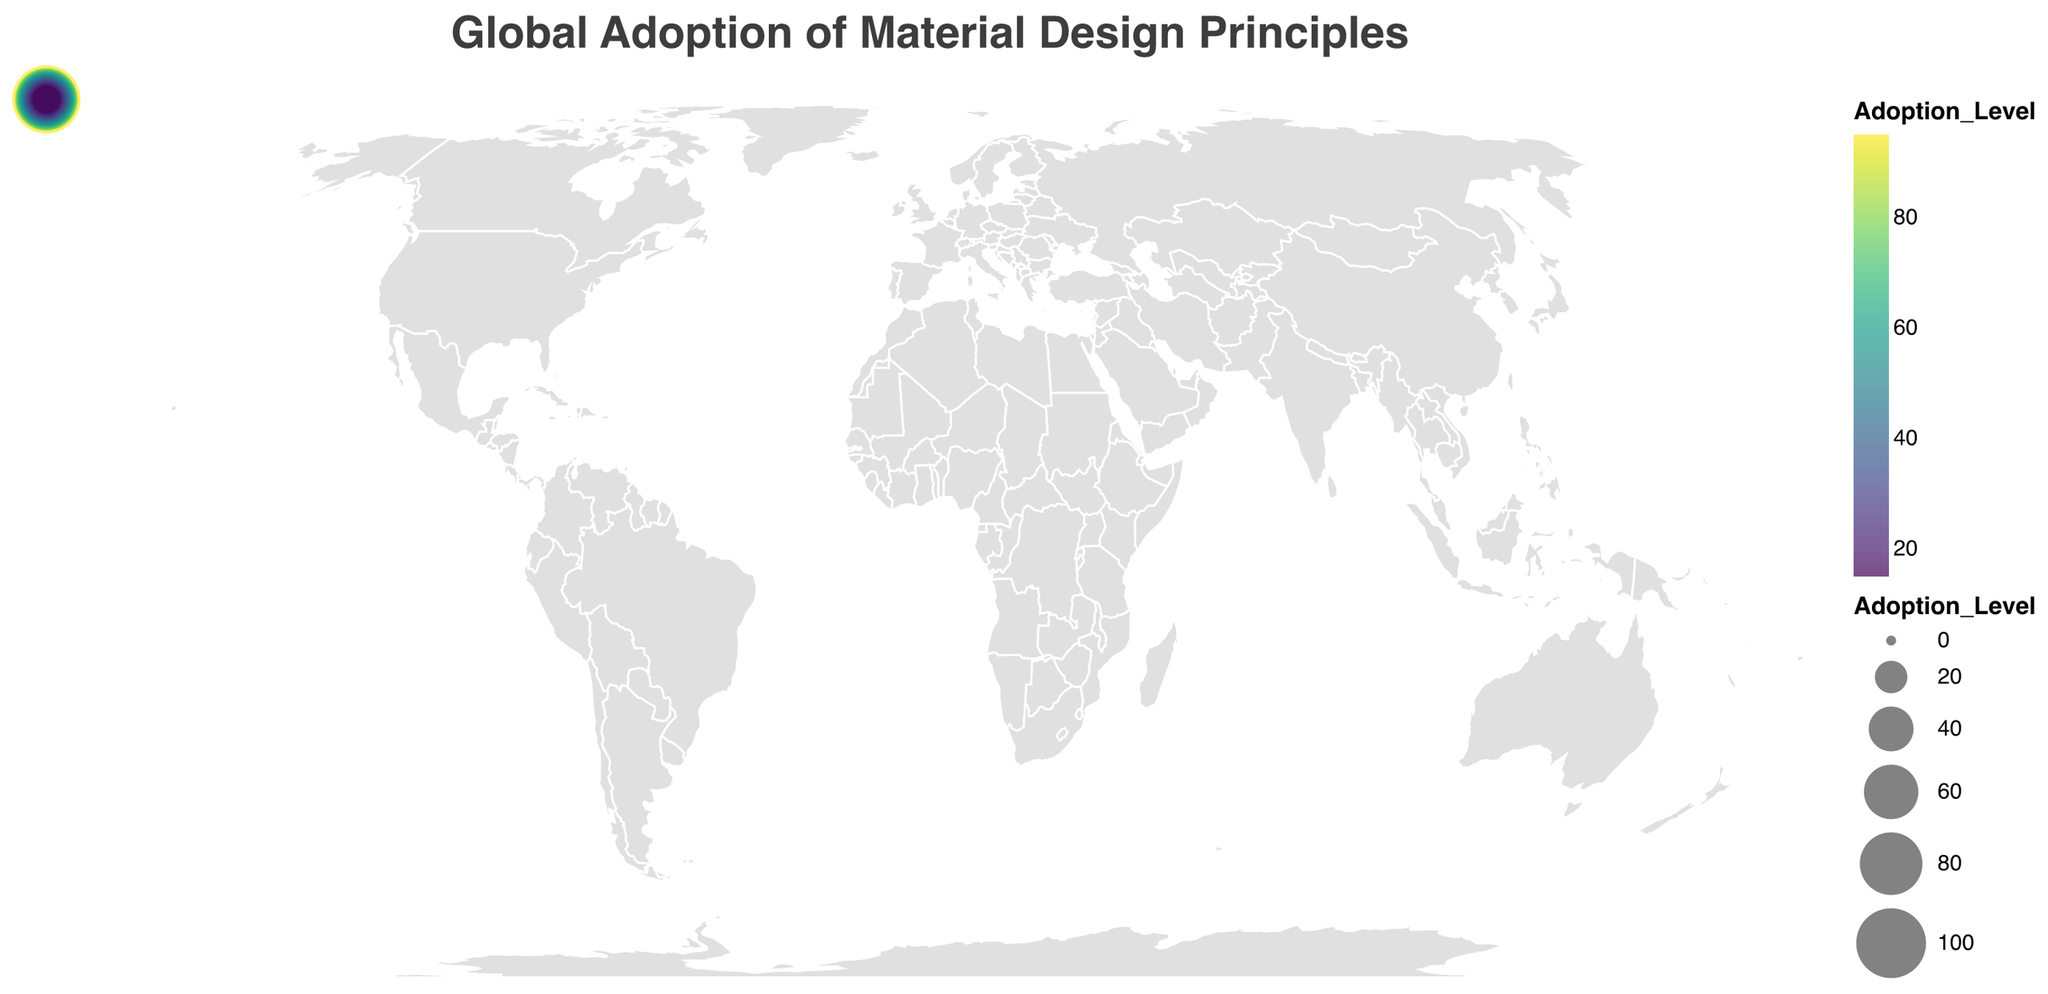What is the title of the geographic plot? The title of the plot is displayed at the top and reads "Global Adoption of Material Design Principles".
Answer: Global Adoption of Material Design Principles Which company has the highest adoption level of material design principles? By looking at the size and color of the circles representing each company, the largest and darkest circle corresponds to Google in the United States with the highest adoption level of 95.
Answer: Google How many countries have companies that adopted material design principles above a level of 50? We count the circles with adoption levels above 50 by observing the plot. The countries with adoption levels above 50 are the United States, United Kingdom, Japan, Germany, India, and Brazil. So, there are 6 such countries.
Answer: 6 What is the adoption level difference between Google and Spotify? Google's adoption level is 95 and Spotify's is 45. Subtracting 45 from 95 gives us the difference.
Answer: 50 Which country has the lowest adoption level of material design principles? By identifying the smallest and lightest colored circle, Italy has the company "Bending Spoons" with the lowest adoption level of 15.
Answer: Italy Compare the adoption levels of material design principles between the companies in Asian countries. The Asian countries listed are India (Flipkart, 65), Japan (Sony, 75), South Korea (Samsung, 40), and Singapore (Grab, 30). Comparing these levels, Sony in Japan has the highest adoption among them.
Answer: Sony (Japan) has the highest adoption level In which continents are the top three companies with the highest adoption levels located? The top three companies by adoption levels are Google in the United States (North America), BBC in the United Kingdom (Europe), and Sony in Japan (Asia).
Answer: North America, Europe, Asia Calculate the average adoption level of the companies located in Europe. The European countries listed are the United Kingdom (BBC, 80), Germany (Adidas, 70), Sweden (Spotify, 45), France (Deezer, 35), Netherlands (Booking.com, 25), Spain (BBVA, 20), and Italy (Bending Spoons, 15). Summing these levels (80 + 70 + 45 + 35 + 25 + 20 + 15) gives 290, and dividing by 7 (number of countries) results in an average of 41.4.
Answer: 41.4 Identify the color scheme used in the plot and its significance. The plot uses a "viridis" color scheme. The colors range from lighter to darker shades, indicating lower to higher adoption levels of material design principles, respectively.
Answer: Viridis Which company in South America has adopted material design principles and at what level? By identifying the country in South America, Brazil (Nubank) is the company with an adoption level of 60.
Answer: Nubank, 60 